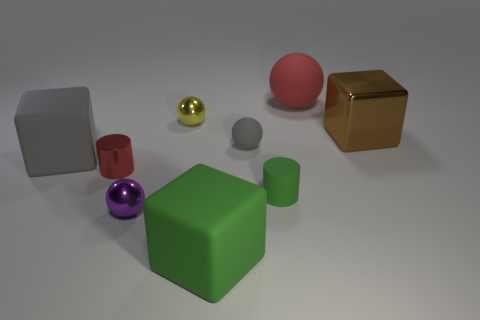Subtract all blue cubes. Subtract all brown cylinders. How many cubes are left? 3 Subtract all spheres. How many objects are left? 5 Subtract all yellow shiny cylinders. Subtract all red things. How many objects are left? 7 Add 2 small things. How many small things are left? 7 Add 1 small gray rubber spheres. How many small gray rubber spheres exist? 2 Subtract 0 brown spheres. How many objects are left? 9 